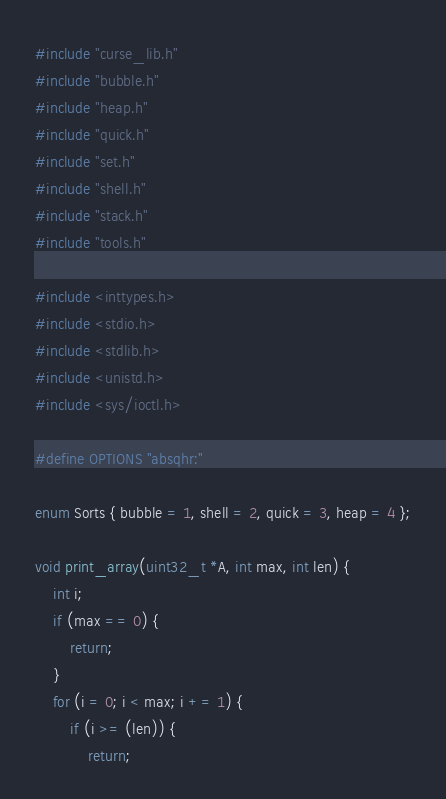<code> <loc_0><loc_0><loc_500><loc_500><_C_>#include "curse_lib.h"
#include "bubble.h"
#include "heap.h"
#include "quick.h"
#include "set.h"
#include "shell.h"
#include "stack.h"
#include "tools.h"

#include <inttypes.h>
#include <stdio.h>
#include <stdlib.h>
#include <unistd.h>
#include <sys/ioctl.h>

#define OPTIONS "absqhr:"

enum Sorts { bubble = 1, shell = 2, quick = 3, heap = 4 };

void print_array(uint32_t *A, int max, int len) {
    int i;
    if (max == 0) {
        return;
    }
    for (i = 0; i < max; i += 1) {
        if (i >= (len)) {
            return;</code> 